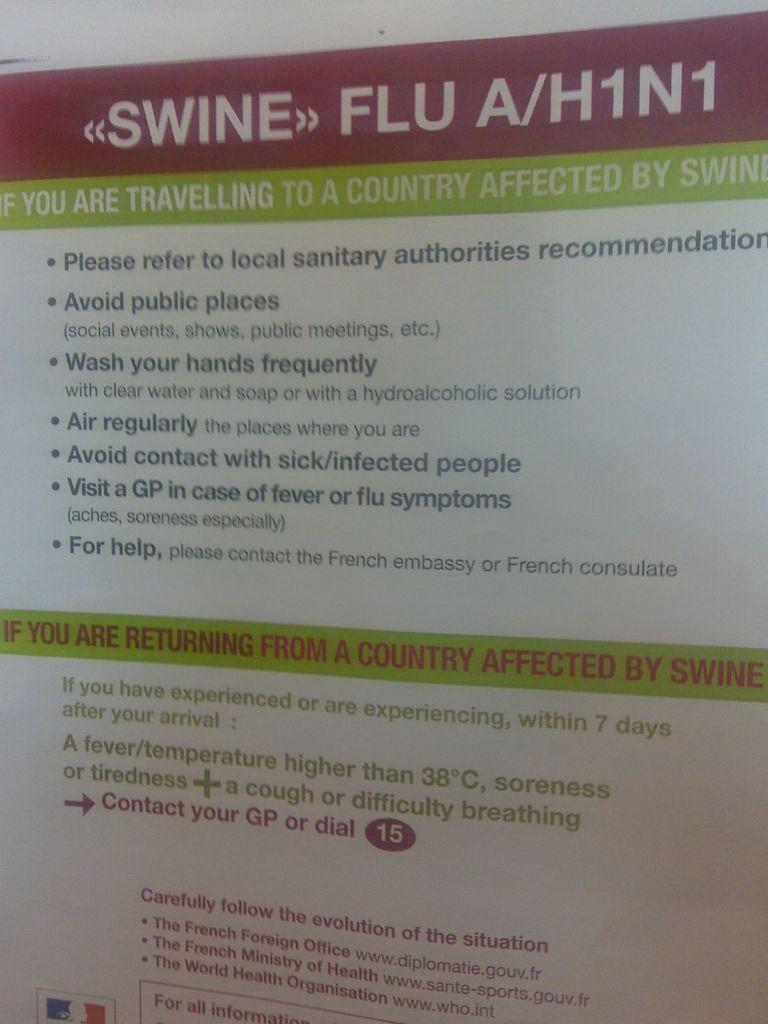Provide a one-sentence caption for the provided image. a piece of paper that talks about swine flu. 